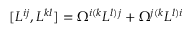Convert formula to latex. <formula><loc_0><loc_0><loc_500><loc_500>[ L ^ { i j } , L ^ { k l } ] = \Omega ^ { i ( k } L ^ { l ) j } + \Omega ^ { j ( k } L ^ { l ) i }</formula> 